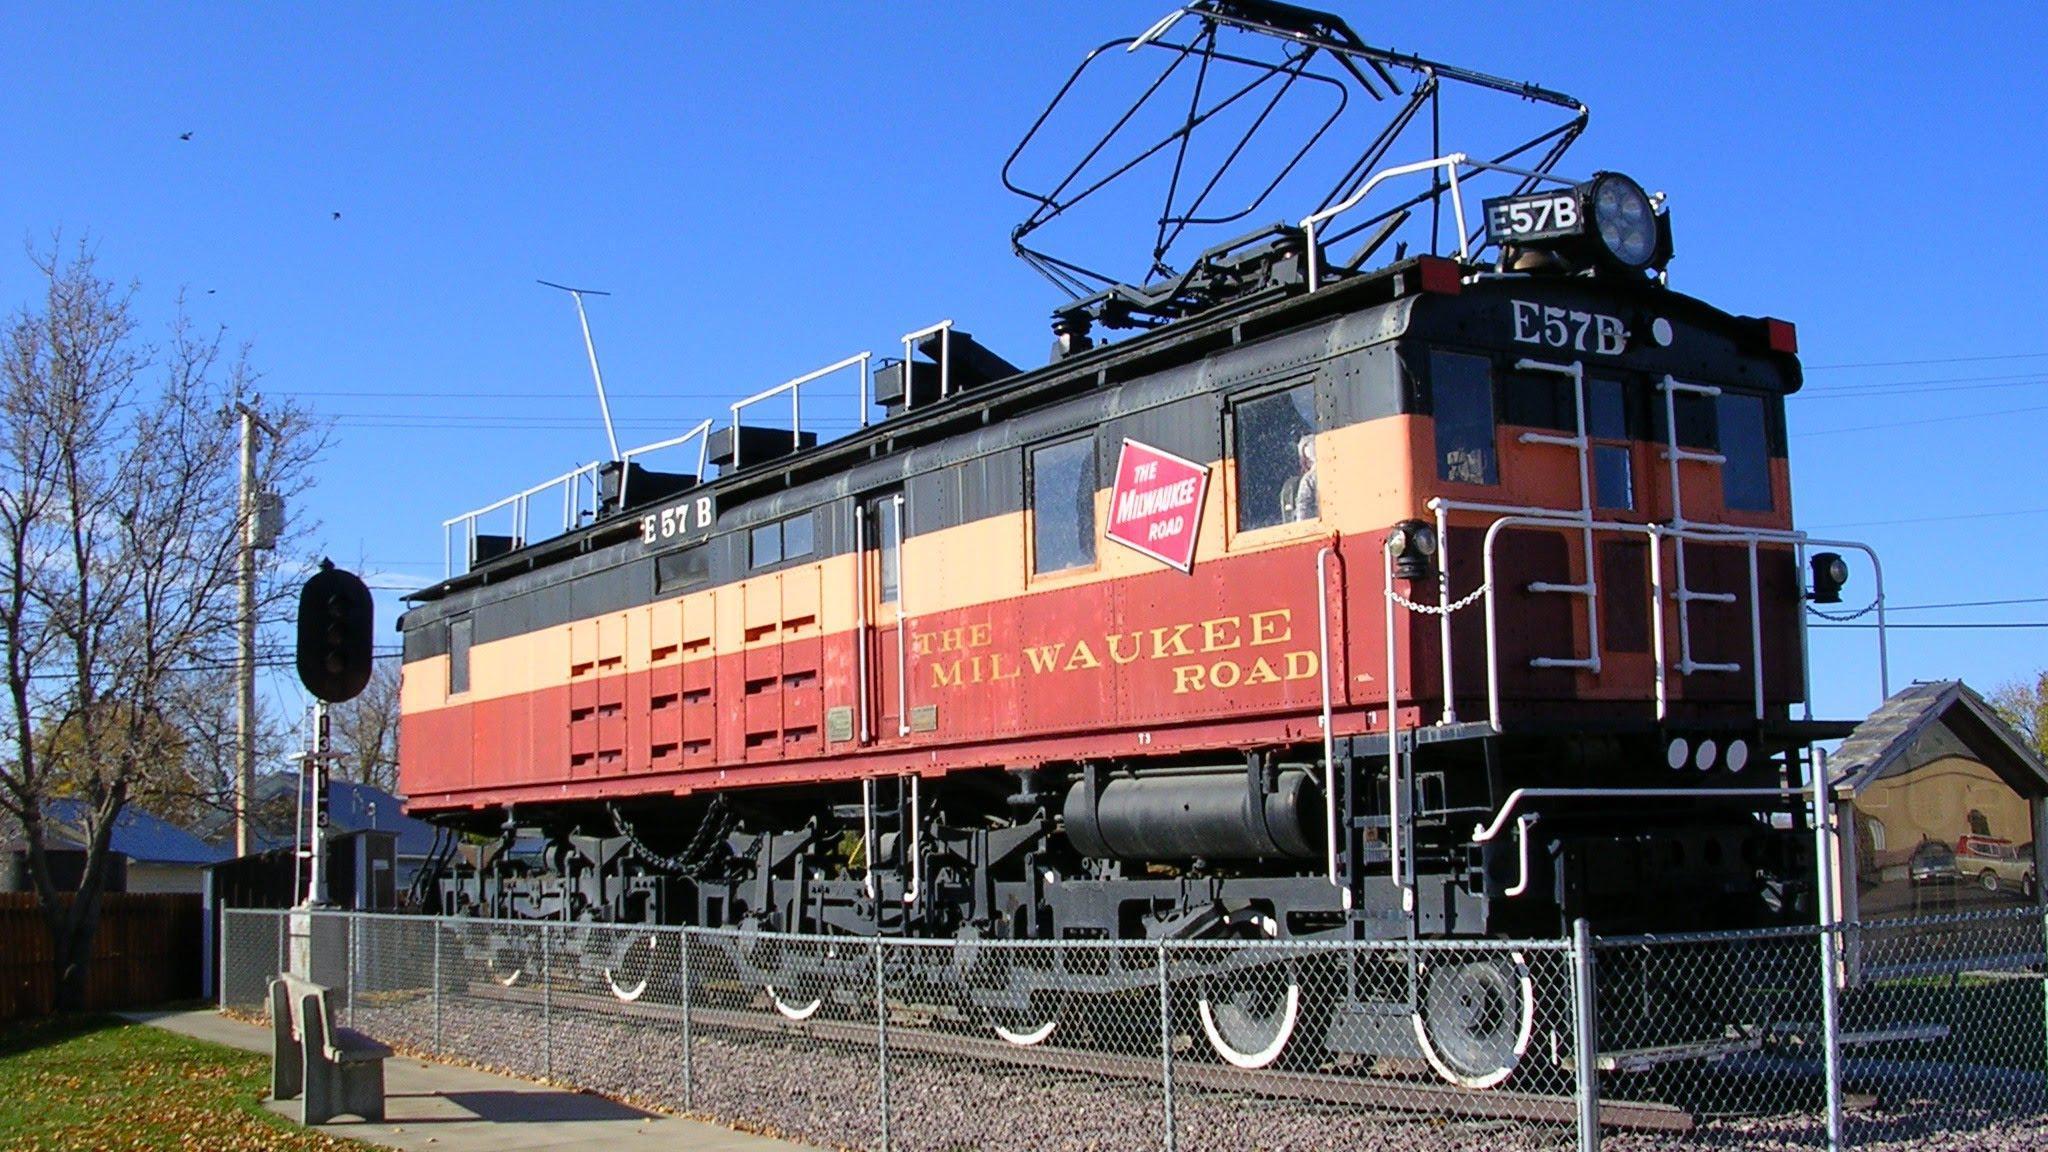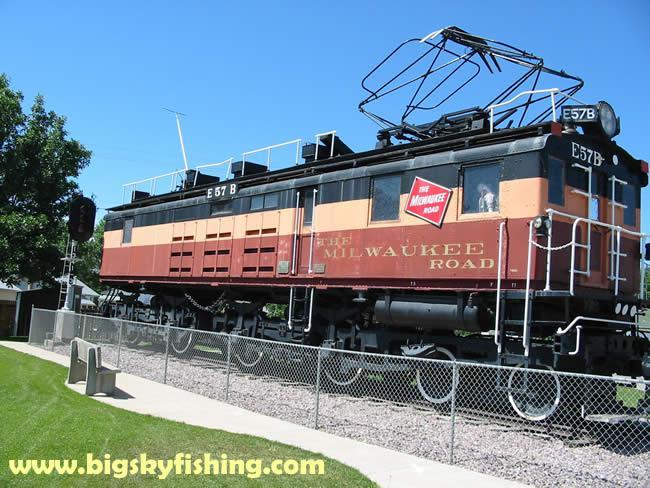The first image is the image on the left, the second image is the image on the right. Considering the images on both sides, is "Two trains are angled in different directions." valid? Answer yes or no. No. The first image is the image on the left, the second image is the image on the right. Given the left and right images, does the statement "there are no power poles in the image on the right" hold true? Answer yes or no. Yes. 